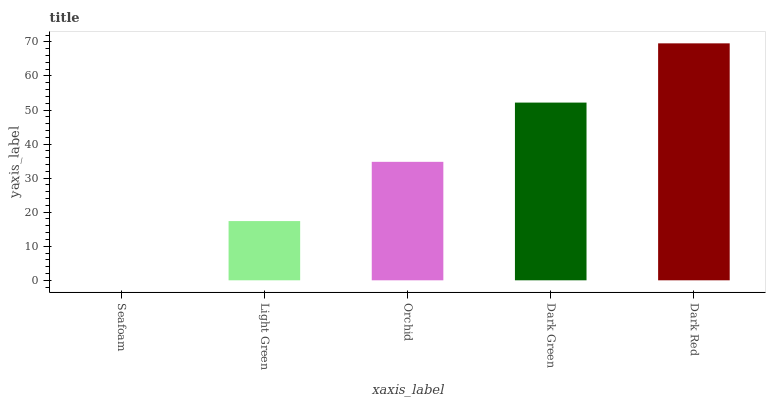Is Seafoam the minimum?
Answer yes or no. Yes. Is Dark Red the maximum?
Answer yes or no. Yes. Is Light Green the minimum?
Answer yes or no. No. Is Light Green the maximum?
Answer yes or no. No. Is Light Green greater than Seafoam?
Answer yes or no. Yes. Is Seafoam less than Light Green?
Answer yes or no. Yes. Is Seafoam greater than Light Green?
Answer yes or no. No. Is Light Green less than Seafoam?
Answer yes or no. No. Is Orchid the high median?
Answer yes or no. Yes. Is Orchid the low median?
Answer yes or no. Yes. Is Light Green the high median?
Answer yes or no. No. Is Dark Green the low median?
Answer yes or no. No. 